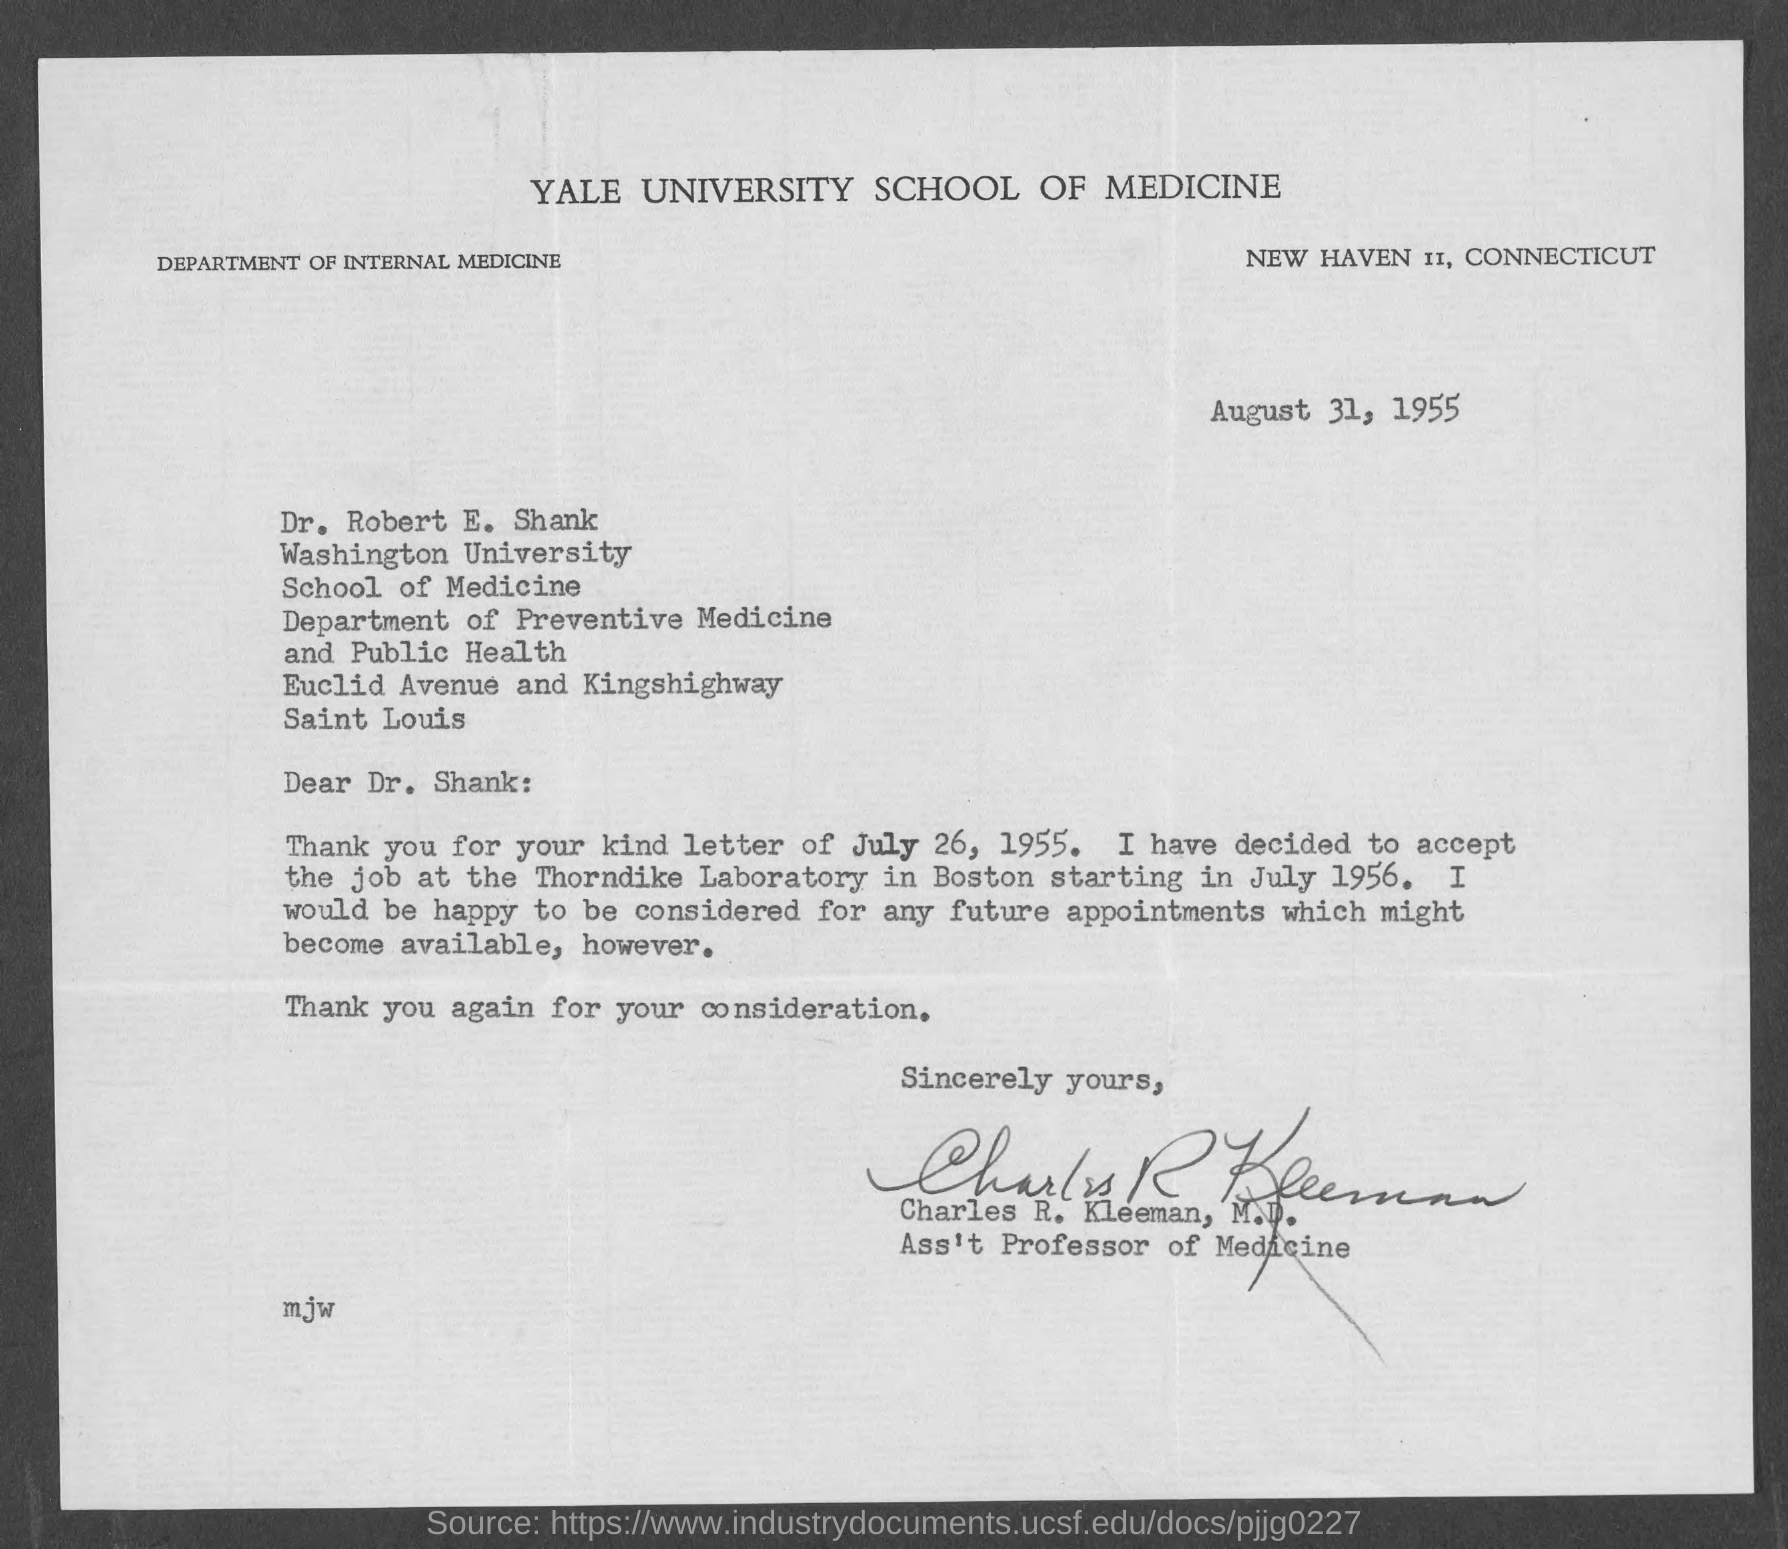Point out several critical features in this image. On July 1956, he decided to accept the job at the Thorndike Laboratory in Boston. Dr. Robert E. Shank is affiliated with Washington University. The date mentioned is August 31, 1955. The letter is written by Charles R. Kleeman. Yale University School of Medicine is located in New Haven, Connecticut. 